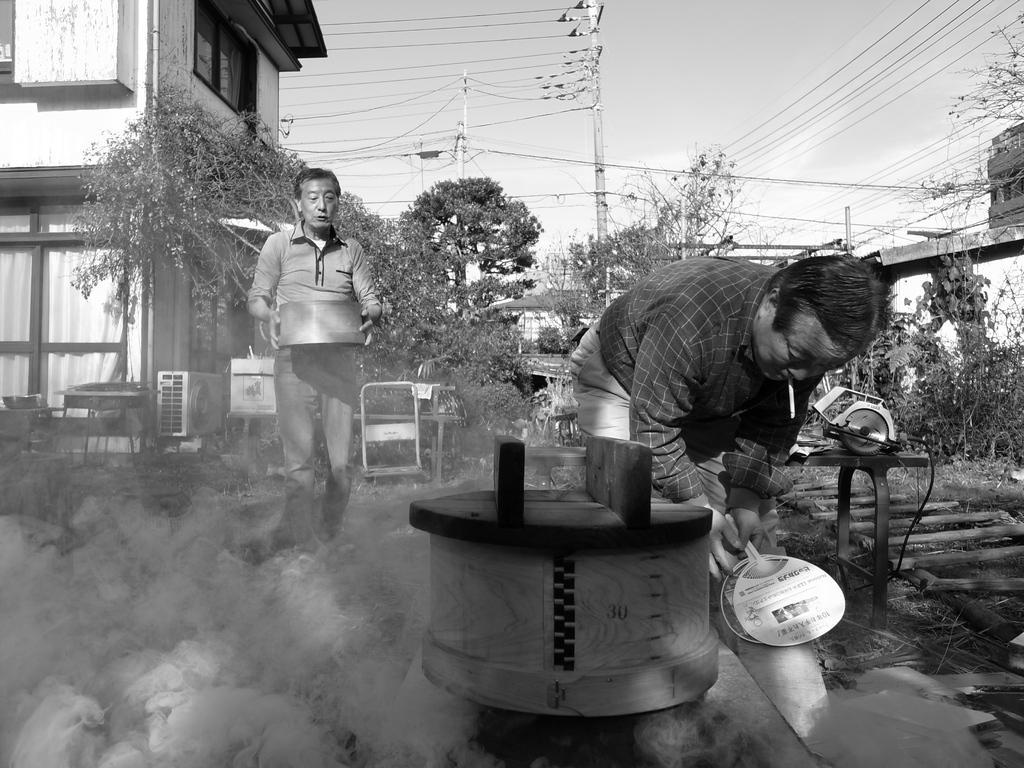Can you describe this image briefly? There are two men here. In front of them there is a lot of smoke here which is coming from a machine. In the background there are some trees, poles, building and a sky here. 